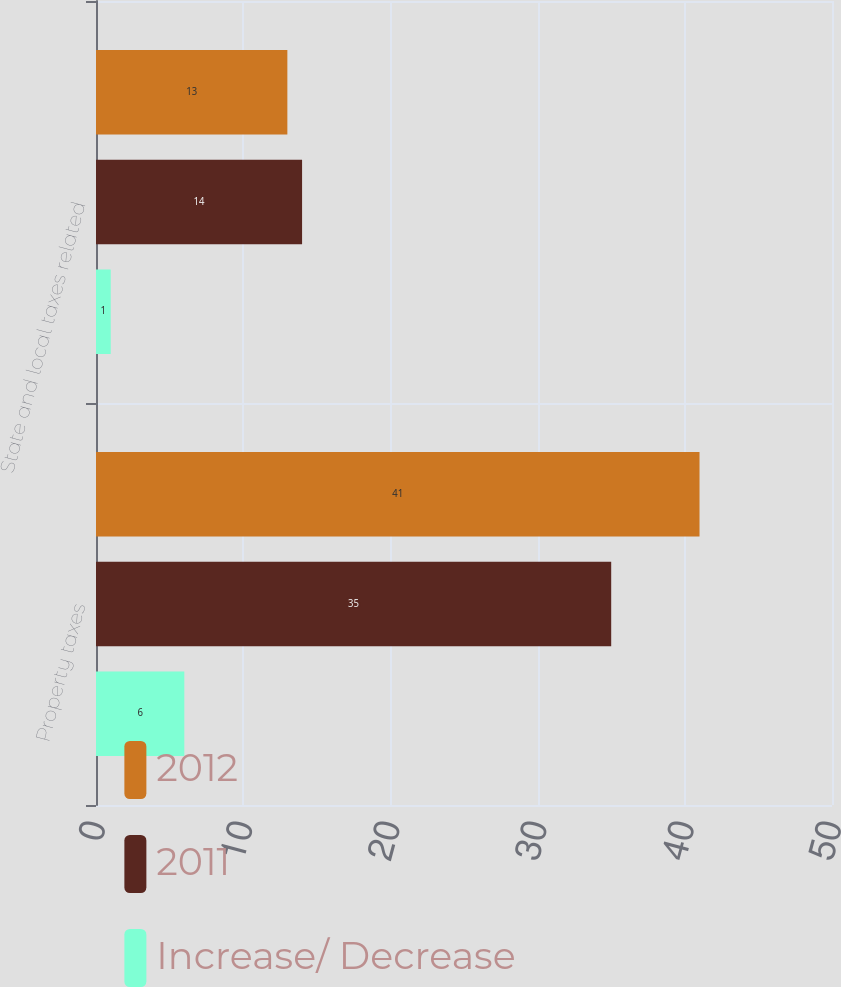<chart> <loc_0><loc_0><loc_500><loc_500><stacked_bar_chart><ecel><fcel>Property taxes<fcel>State and local taxes related<nl><fcel>2012<fcel>41<fcel>13<nl><fcel>2011<fcel>35<fcel>14<nl><fcel>Increase/ Decrease<fcel>6<fcel>1<nl></chart> 